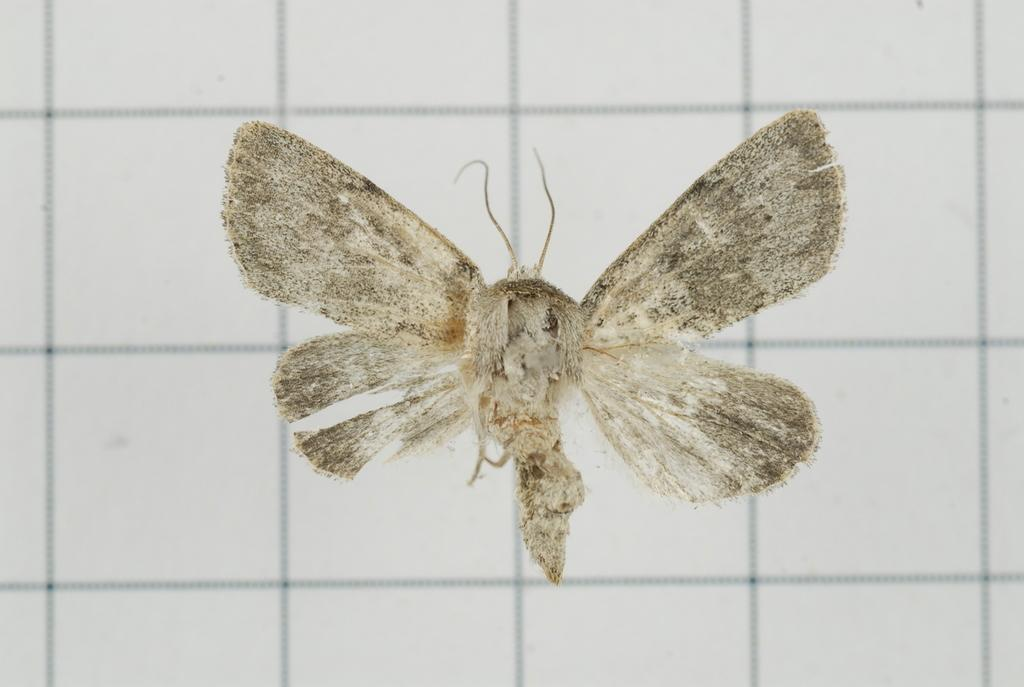What is the main subject of the picture? The main subject of the picture is an insect. Where is the insect located in the image? The insect is on a white surface. What can be observed on the white surface besides the insect? There are black lines on the surface. What type of cream can be seen on the insect in the image? There is no cream present on the insect in the image. What is the name of the downtown area visible in the background of the image? There is no downtown area visible in the image, as it only features an insect on a white surface with black lines. 